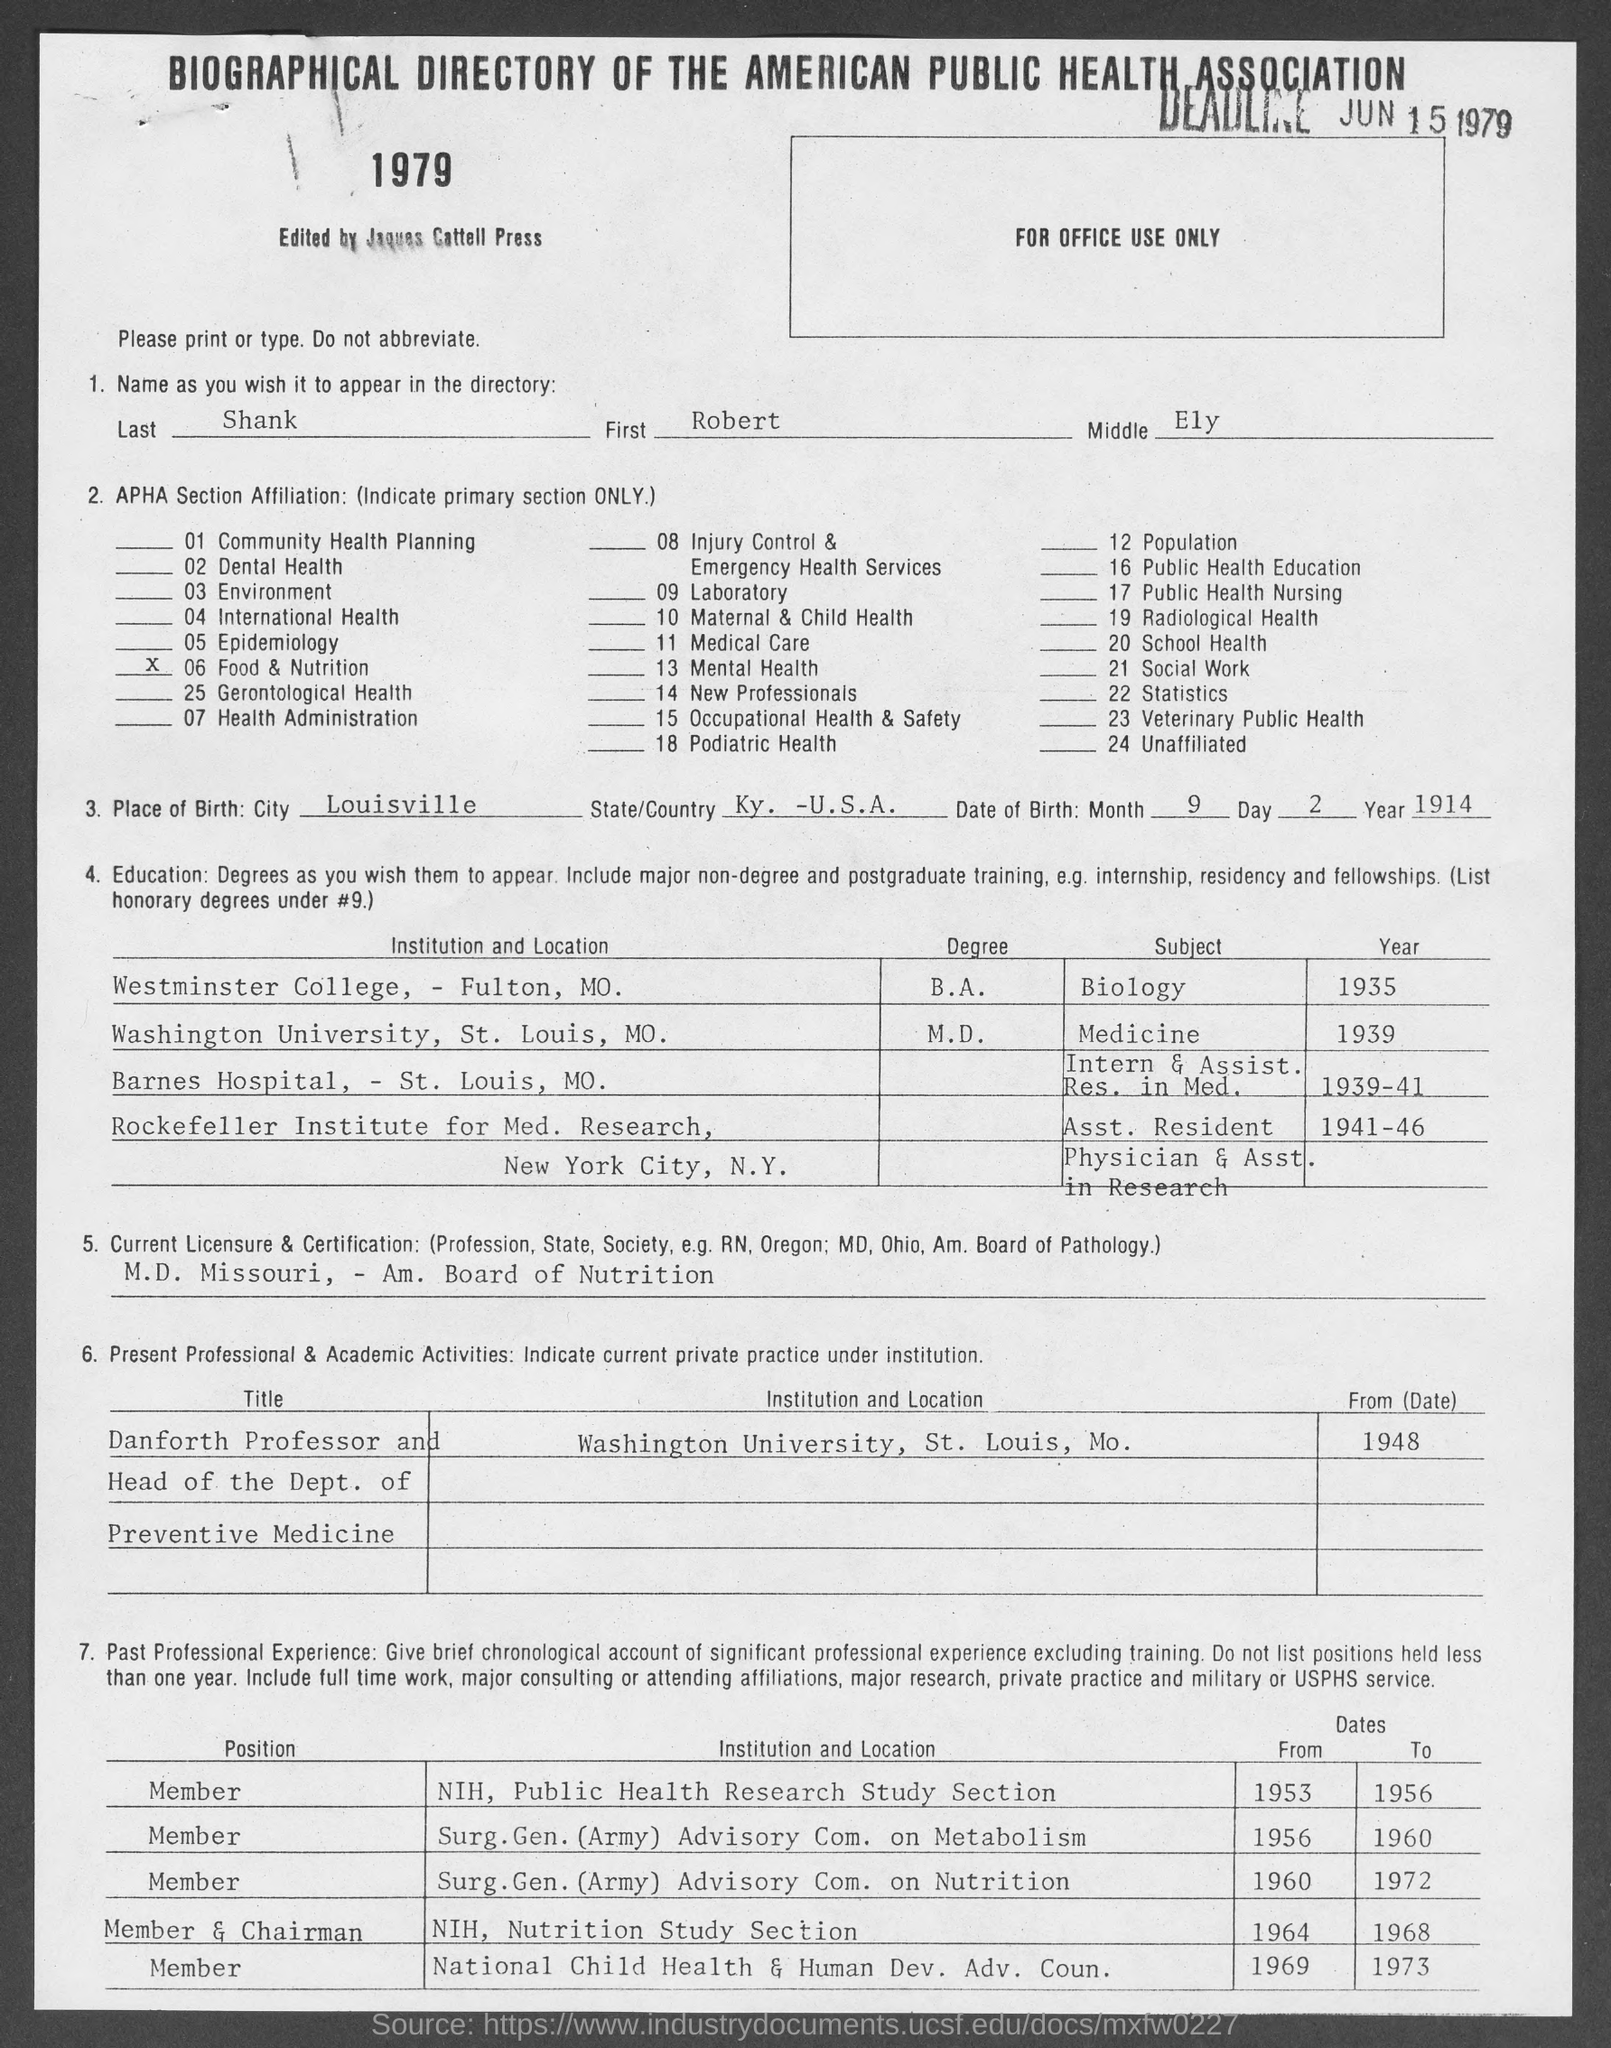When is the deadline?
Offer a very short reply. JUN 15 1979. What is the Last name?
Your answer should be compact. Shank. What is the First Name?
Give a very brief answer. Robert. What is the Middle name?
Keep it short and to the point. Ely. What is the place of birth city?
Give a very brief answer. Louisville. What is the place of birth state?
Offer a very short reply. Ky. -U.S.A. What is the current licensure & certification?
Provide a succinct answer. M.D. Missouri, - Am. Board of Nutrition. Which year was he in Westminster college?
Provide a succinct answer. 1935. 